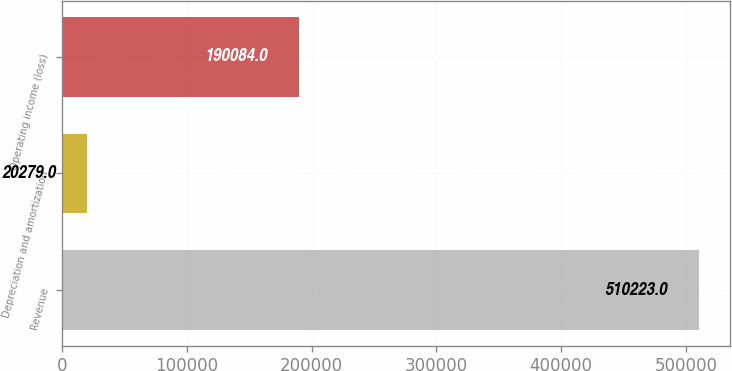Convert chart. <chart><loc_0><loc_0><loc_500><loc_500><bar_chart><fcel>Revenue<fcel>Depreciation and amortization<fcel>Operating income (loss)<nl><fcel>510223<fcel>20279<fcel>190084<nl></chart> 